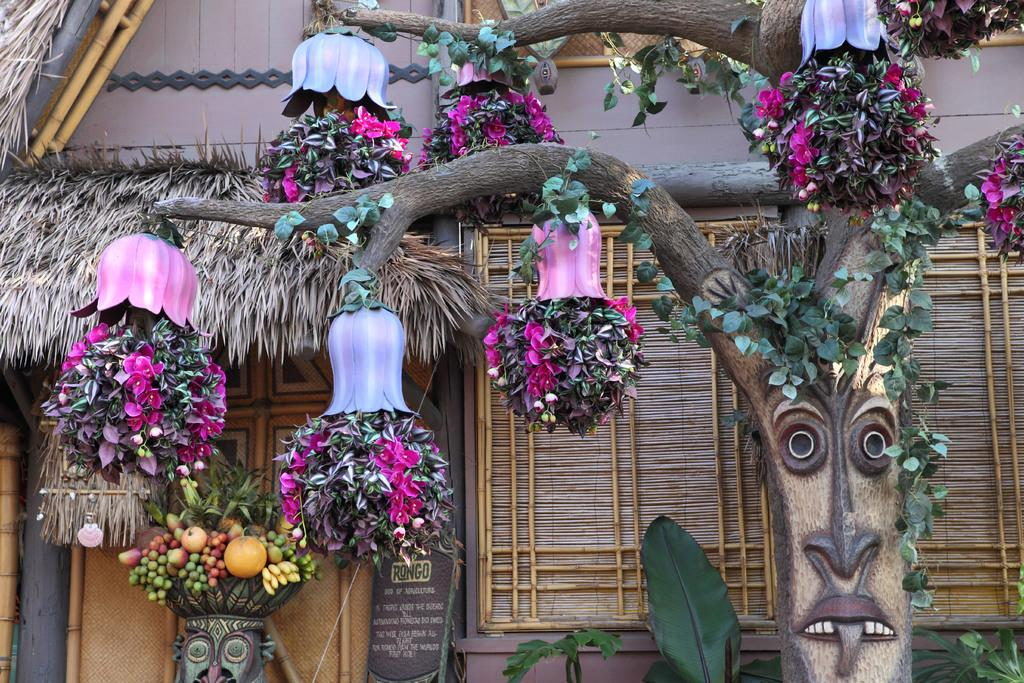What is adorning the tree branches in the image? The tree branches are decorated with leaves and colorful flowers. Can you describe the fruits visible in the image? The fruits are visible on the left side of the image. What type of celery can be seen growing in the image? There is no celery present in the image; it features tree branches decorated with leaves and colorful flowers, as well as fruits. Is there any quicksand visible in the image? No, there is no quicksand present in the image. 